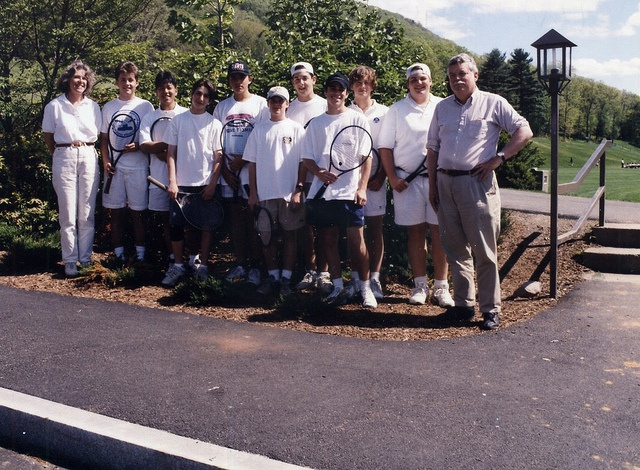Describe the objects in this image and their specific colors. I can see people in black, gray, and lightgray tones, people in black, darkgray, lightgray, and gray tones, people in black, lightgray, maroon, and darkgray tones, people in black, lightgray, darkgray, and gray tones, and people in black, gray, and lightgray tones in this image. 